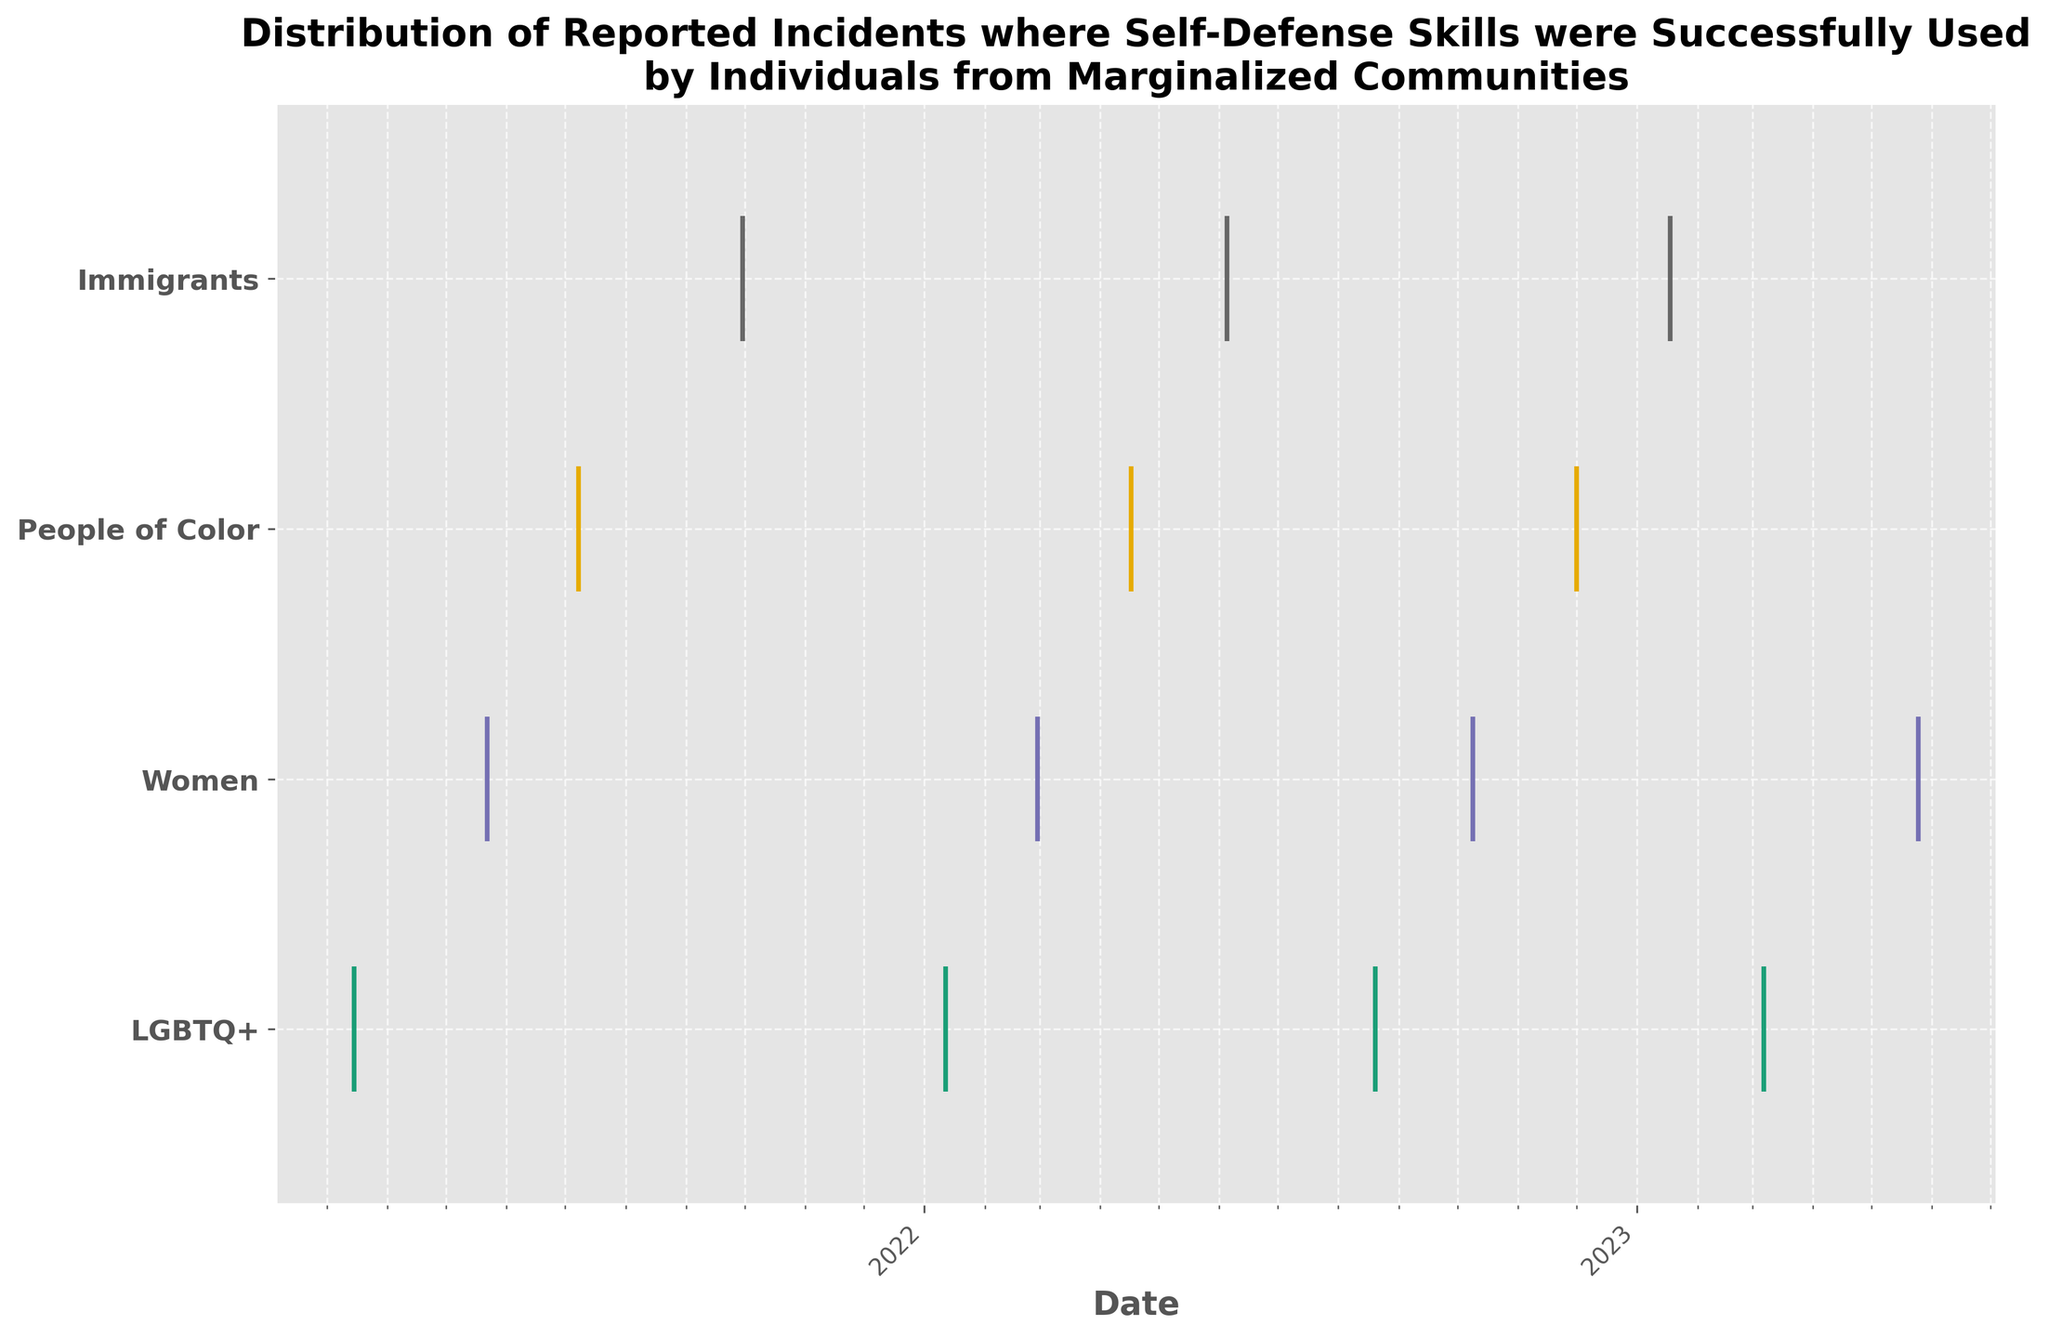What is the title of the figure? The title is displayed at the top of the figure in bold text.
Answer: Distribution of Reported Incidents where Self-Defense Skills were Successfully Used by Individuals from Marginalized Communities Which groups are represented in the figure? The groups are labeled on the y-axis.
Answer: LGBTQ+, Women, People of Color, Immigrants How is the x-axis of the figure labeled? The x-axis label is located below the axis.
Answer: Date What are the different color lines representing? Each color line represents a different group, as indicated by the unique colors associated with each group on the y-axis.
Answer: Distribution of incidents for each group Which group has reported incidents in the most cities? By counting the number of distinct y-coordinates for each group across the x-axis, we can identify the group with the most cities.
Answer: Women (6 cities) In which month did 'People of Color' group report incidents in 2022? Locate the 'People of Color' line for 2022 on the x-axis and read the specific months.
Answer: April and December How many distinct reporting dates are there for the 'Immigrants' group? Count the number of event points along the 'Immigrants' line on the y-axis.
Answer: 4 Which year has the highest number of reported incidents across all groups combined? Observe the clustering of event points along the x-axis labeled by year, evaluating which year has the most points.
Answer: 2022 Compare the number of incidents reported by LGBTQ+ in 2021 and 2022. Which year had more incidents? Count the number of event points for LGBTQ+ in 2021 and 2022 and compare them.
Answer: 2022 What is the total number of incidents reported by all groups in 2023? Sum the number of event points along the x-axis for the year 2023.
Answer: 2 